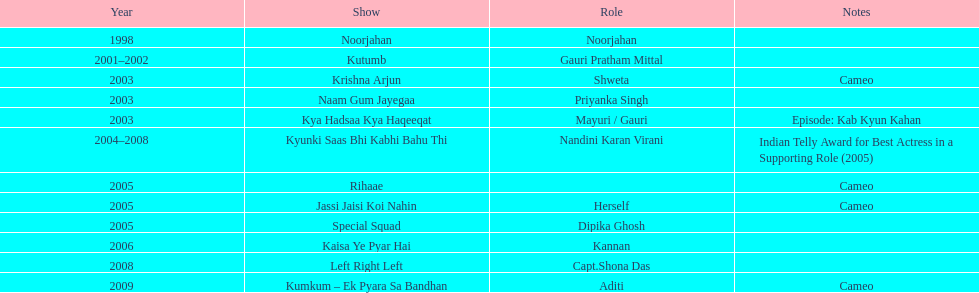Which was the only television show gauri starred in, in which she played herself? Jassi Jaisi Koi Nahin. 